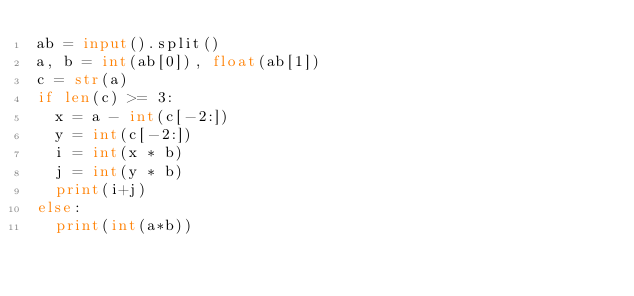<code> <loc_0><loc_0><loc_500><loc_500><_Python_>ab = input().split()
a, b = int(ab[0]), float(ab[1])
c = str(a)
if len(c) >= 3:
  x = a - int(c[-2:])
  y = int(c[-2:])
  i = int(x * b)
  j = int(y * b)
  print(i+j)
else:
  print(int(a*b))</code> 